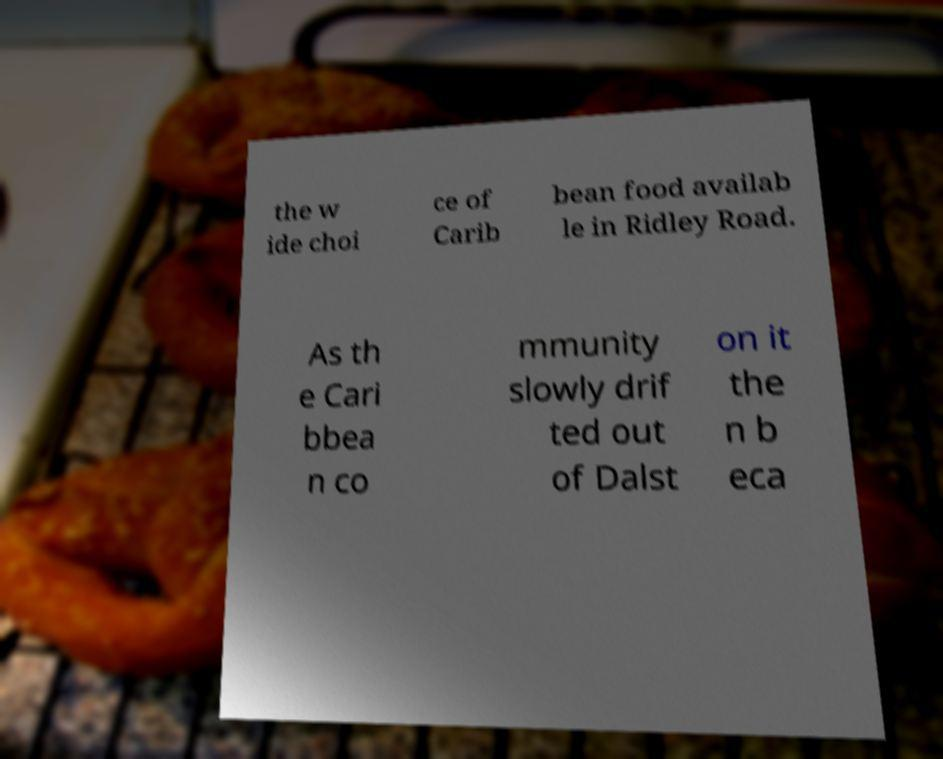There's text embedded in this image that I need extracted. Can you transcribe it verbatim? the w ide choi ce of Carib bean food availab le in Ridley Road. As th e Cari bbea n co mmunity slowly drif ted out of Dalst on it the n b eca 